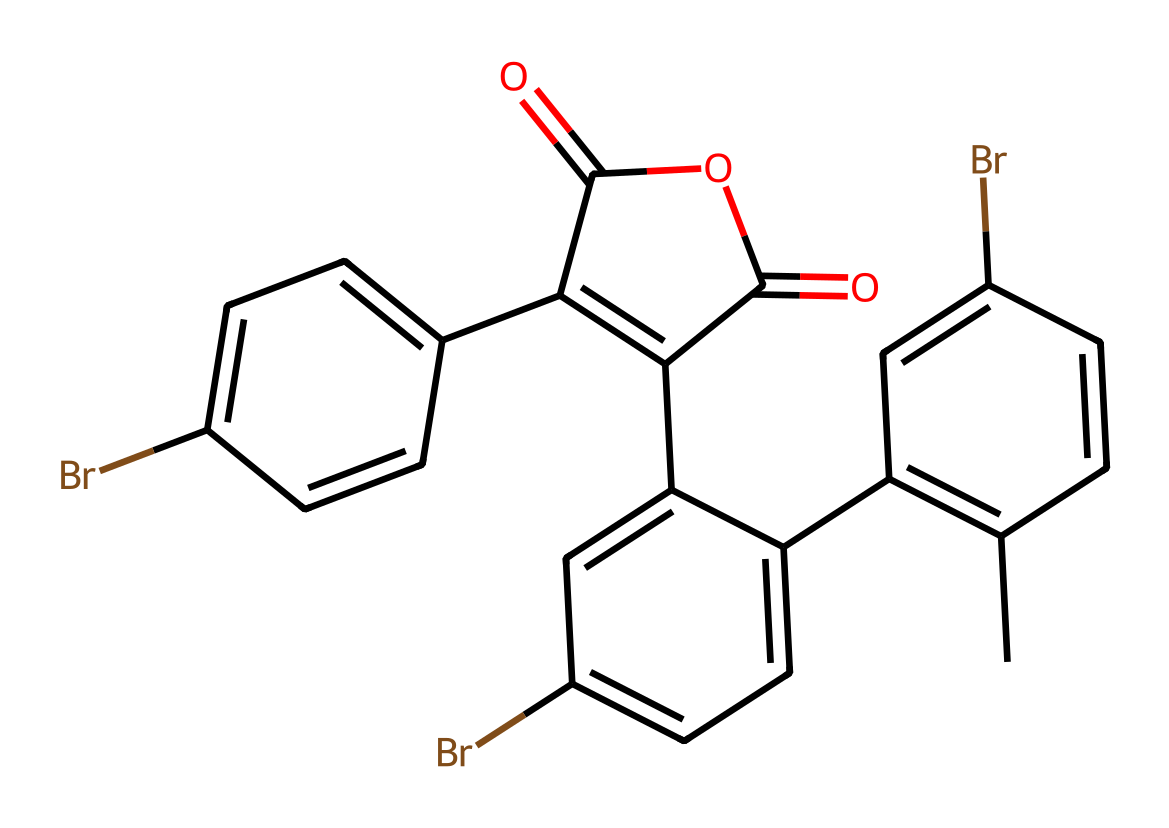What is the main functional group present in the chemical? The chemical contains an ester functional group characterized by the presence of a carbonyl (C=O) adjacent to an oxygen atom (C-O), which is indicated by the part of the structure with the notation "C(=O)OC".
Answer: ester How many bromine atoms are found in the chemical? The structure features multiple instances of the bromine atom, denoted by "Br". Counting these occurrences reveals a total of three bromine atoms in different positions of the structure.
Answer: three Which part of the chemical suggests it may have photochromic properties? The multiple conjugated double bonds (C=C) alternating with the bromine atoms in the structure suggest extensive pi-electron delocalization, a characteristic that contributes to its photochromic behavior by allowing electronic transitions upon light exposure.
Answer: conjugated double bonds What is the total number of rings present in the structure? By analyzing the structure, the presence of multiple cyclic components indicates a total of four interconnected rings, linked through carbon atoms and the attachment of other groups.
Answer: four What role does bromine play in this chemical's properties? Bromine acts as an electron-withdrawing group due to its electronegativity, which can enhance the stability of the excited state of the photochromic compound, making it more responsive to light, thus influencing its reactivity and bonding behavior.
Answer: electron-withdrawing What type of bond connects the carbon and bromine atoms in the structure? The bonding between carbon and bromine in the structure involves a covalent bond, as bromine is connected to carbon through a single bond that is characteristic of halogen substitution on carbon centers.
Answer: covalent bond 